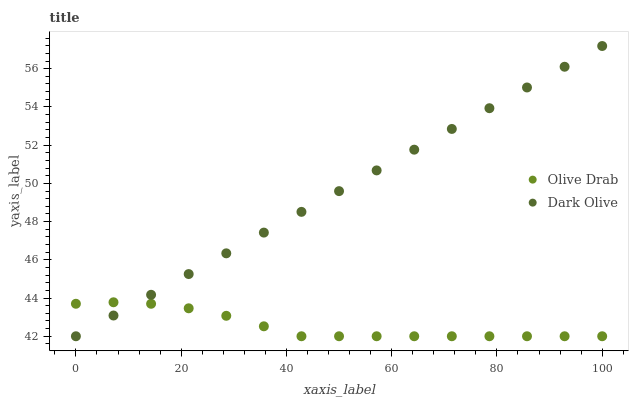Does Olive Drab have the minimum area under the curve?
Answer yes or no. Yes. Does Dark Olive have the maximum area under the curve?
Answer yes or no. Yes. Does Olive Drab have the maximum area under the curve?
Answer yes or no. No. Is Dark Olive the smoothest?
Answer yes or no. Yes. Is Olive Drab the roughest?
Answer yes or no. Yes. Is Olive Drab the smoothest?
Answer yes or no. No. Does Dark Olive have the lowest value?
Answer yes or no. Yes. Does Dark Olive have the highest value?
Answer yes or no. Yes. Does Olive Drab have the highest value?
Answer yes or no. No. Does Olive Drab intersect Dark Olive?
Answer yes or no. Yes. Is Olive Drab less than Dark Olive?
Answer yes or no. No. Is Olive Drab greater than Dark Olive?
Answer yes or no. No. 